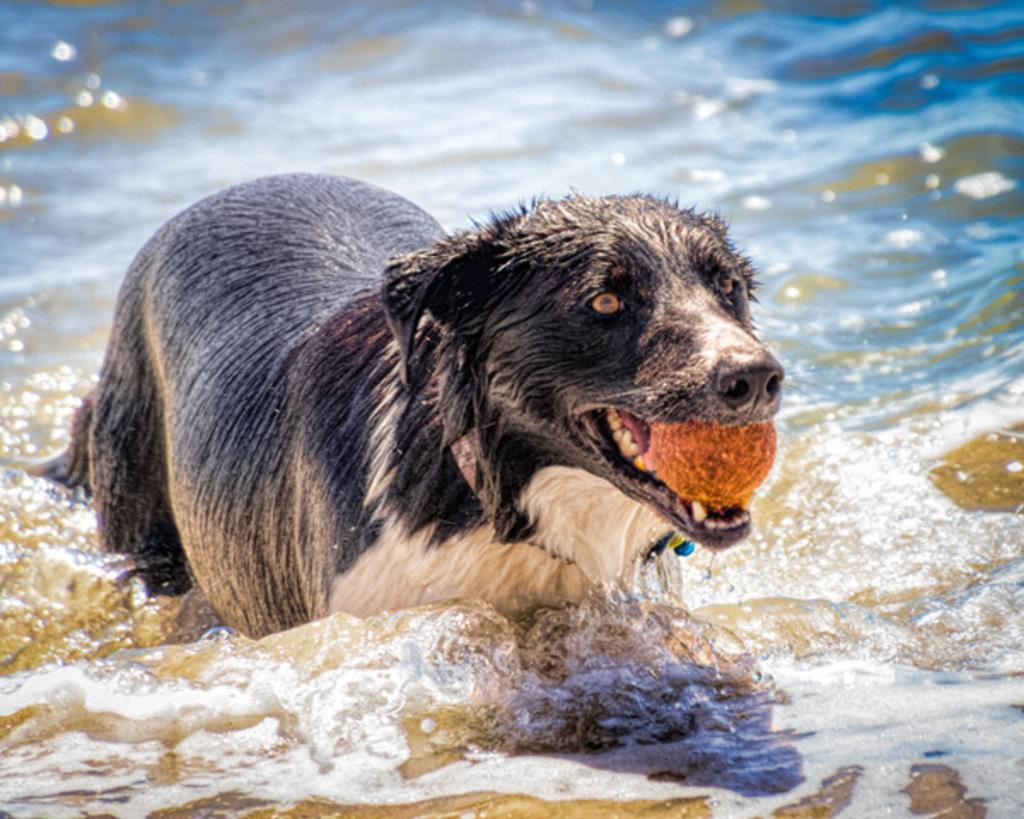What type of animal is in the image? There is a black color dog in the image. What is the dog holding in its mouth? The dog is holding a brown color ball in its mouth. Where is the dog located in the image? The dog is walking in the water. What is the color of the water in the background? The water in the background is blue in color. Is the dog wearing a collar in the image? There is no mention of a collar in the provided facts, so we cannot determine if the dog is wearing a collar or not. 